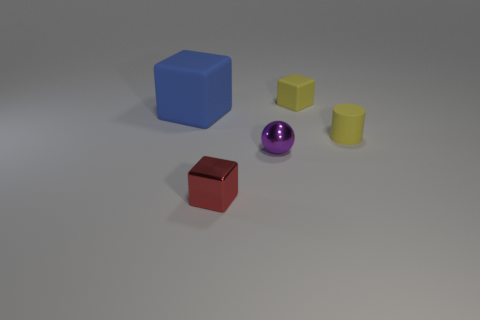Is there a tiny rubber thing that has the same color as the big object?
Your answer should be compact. No. There is another shiny object that is the same size as the red metallic object; what is its color?
Give a very brief answer. Purple. There is a block that is to the right of the tiny red metal block; are there any tiny purple shiny spheres that are behind it?
Offer a terse response. No. There is a tiny block behind the red object; what is it made of?
Provide a short and direct response. Rubber. Do the tiny block that is behind the tiny red shiny block and the tiny block on the left side of the small ball have the same material?
Keep it short and to the point. No. Is the number of purple things in front of the small metallic cube the same as the number of small matte blocks to the left of the big matte thing?
Provide a short and direct response. Yes. How many yellow objects have the same material as the yellow block?
Your answer should be very brief. 1. What shape is the tiny rubber thing that is the same color as the small matte cylinder?
Provide a short and direct response. Cube. There is a rubber object that is left of the small metallic object in front of the tiny metal ball; what is its size?
Offer a terse response. Large. There is a rubber object left of the small red thing; does it have the same shape as the tiny metal thing on the left side of the metallic ball?
Provide a short and direct response. Yes. 